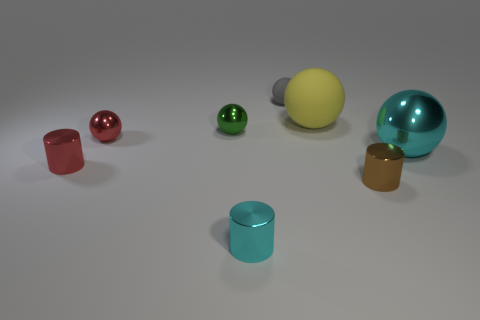Subtract all small red balls. How many balls are left? 4 Subtract 2 cylinders. How many cylinders are left? 1 Add 1 tiny cyan things. How many objects exist? 9 Subtract all gray balls. How many balls are left? 4 Subtract all green blocks. Subtract all yellow objects. How many objects are left? 7 Add 2 red spheres. How many red spheres are left? 3 Add 5 metallic cylinders. How many metallic cylinders exist? 8 Subtract 0 blue blocks. How many objects are left? 8 Subtract all cylinders. How many objects are left? 5 Subtract all gray cylinders. Subtract all gray spheres. How many cylinders are left? 3 